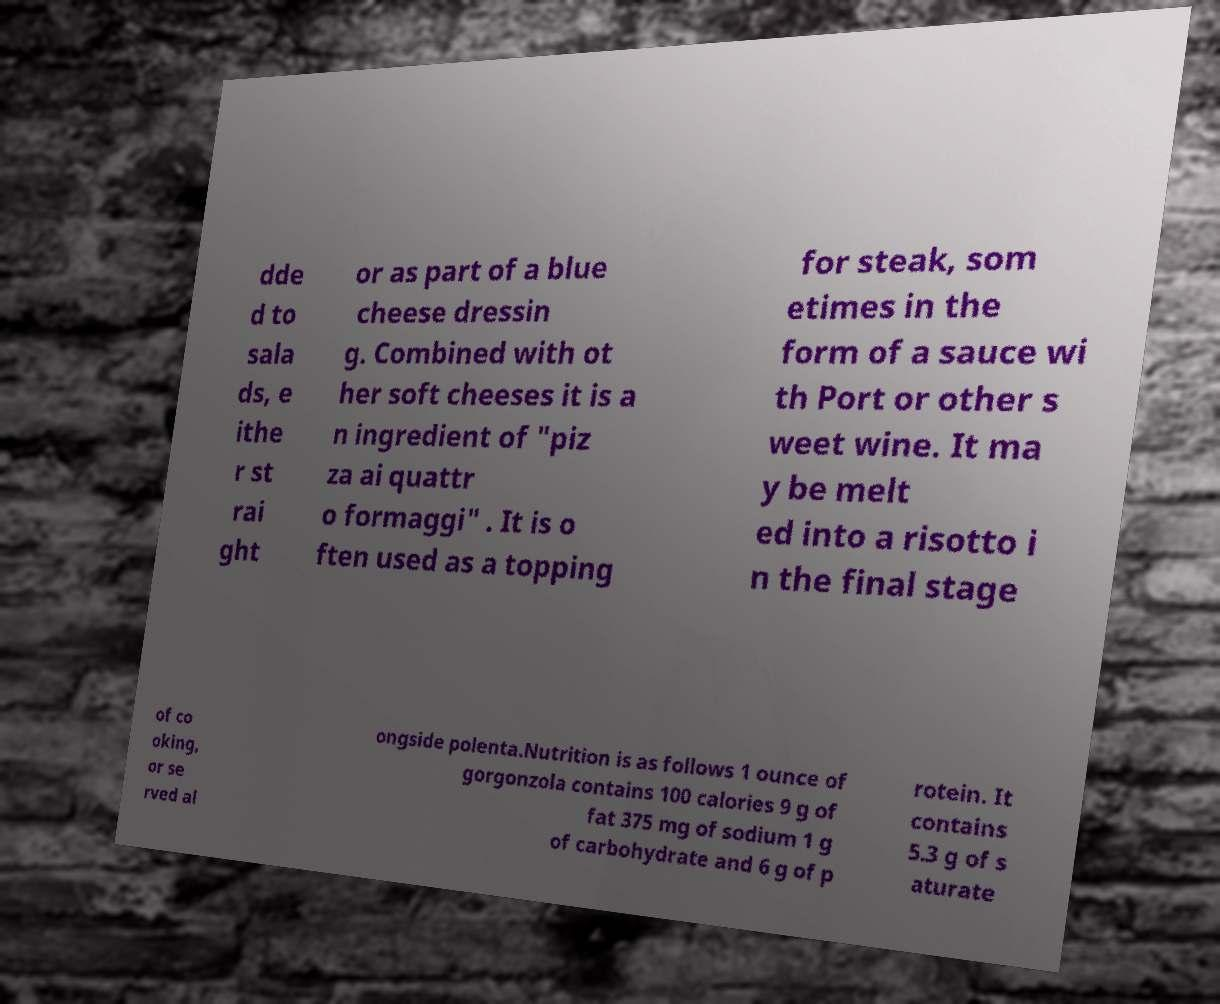For documentation purposes, I need the text within this image transcribed. Could you provide that? dde d to sala ds, e ithe r st rai ght or as part of a blue cheese dressin g. Combined with ot her soft cheeses it is a n ingredient of "piz za ai quattr o formaggi" . It is o ften used as a topping for steak, som etimes in the form of a sauce wi th Port or other s weet wine. It ma y be melt ed into a risotto i n the final stage of co oking, or se rved al ongside polenta.Nutrition is as follows 1 ounce of gorgonzola contains 100 calories 9 g of fat 375 mg of sodium 1 g of carbohydrate and 6 g of p rotein. It contains 5.3 g of s aturate 